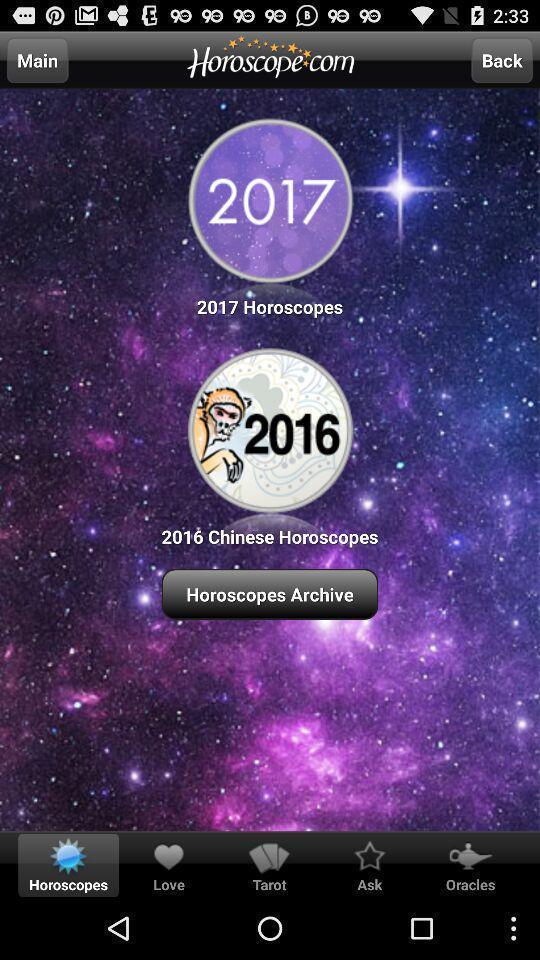Give me a summary of this screen capture. Welcome page of sun signs app. 